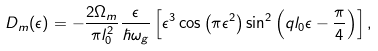<formula> <loc_0><loc_0><loc_500><loc_500>D _ { m } ( \epsilon ) = - \frac { 2 \Omega _ { m } } { \pi l _ { 0 } ^ { 2 } } \frac { \epsilon } { \hbar { \omega } _ { g } } \left [ \epsilon ^ { 3 } \cos \left ( \pi \epsilon ^ { 2 } \right ) \sin ^ { 2 } \left ( q l _ { 0 } \epsilon - \frac { \pi } { 4 } \right ) \right ] ,</formula> 